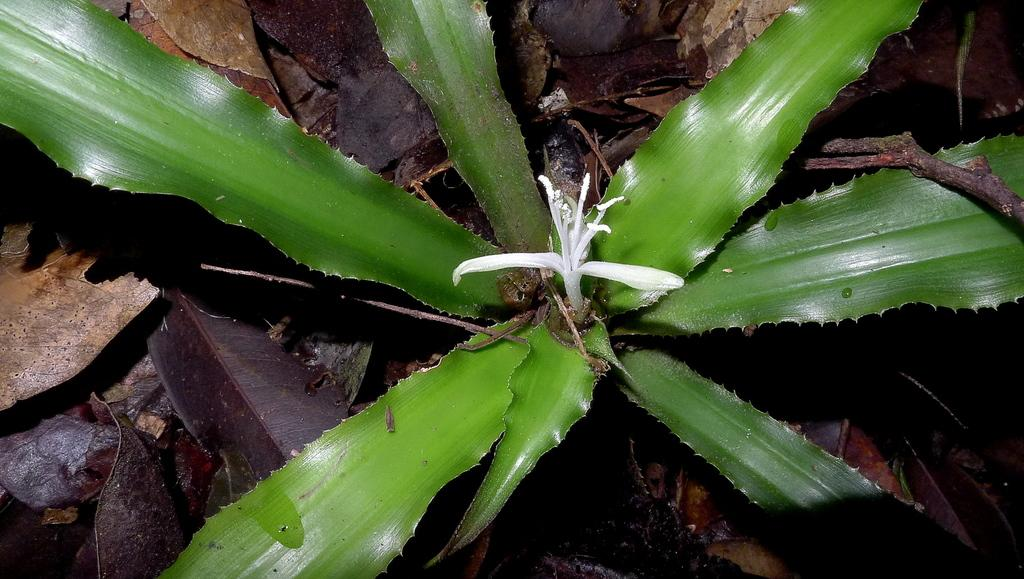What type of living organism can be seen in the image? There is a plant in the image. What is the condition of the plant's leaves in the image? There are dry leaves in the image. What type of pen can be seen in the image? There is no pen present in the image. Is there a bed visible in the image? There is no bed present in the image. 